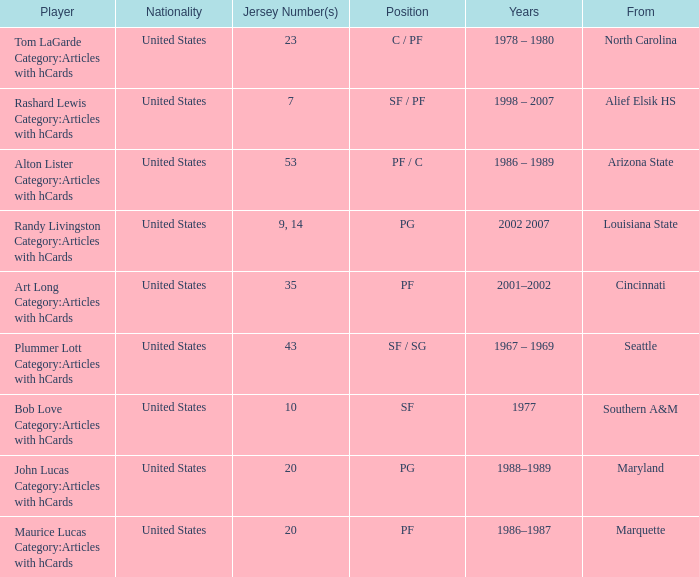Bob Love Category:Articles with hCards is from where? Southern A&M. 